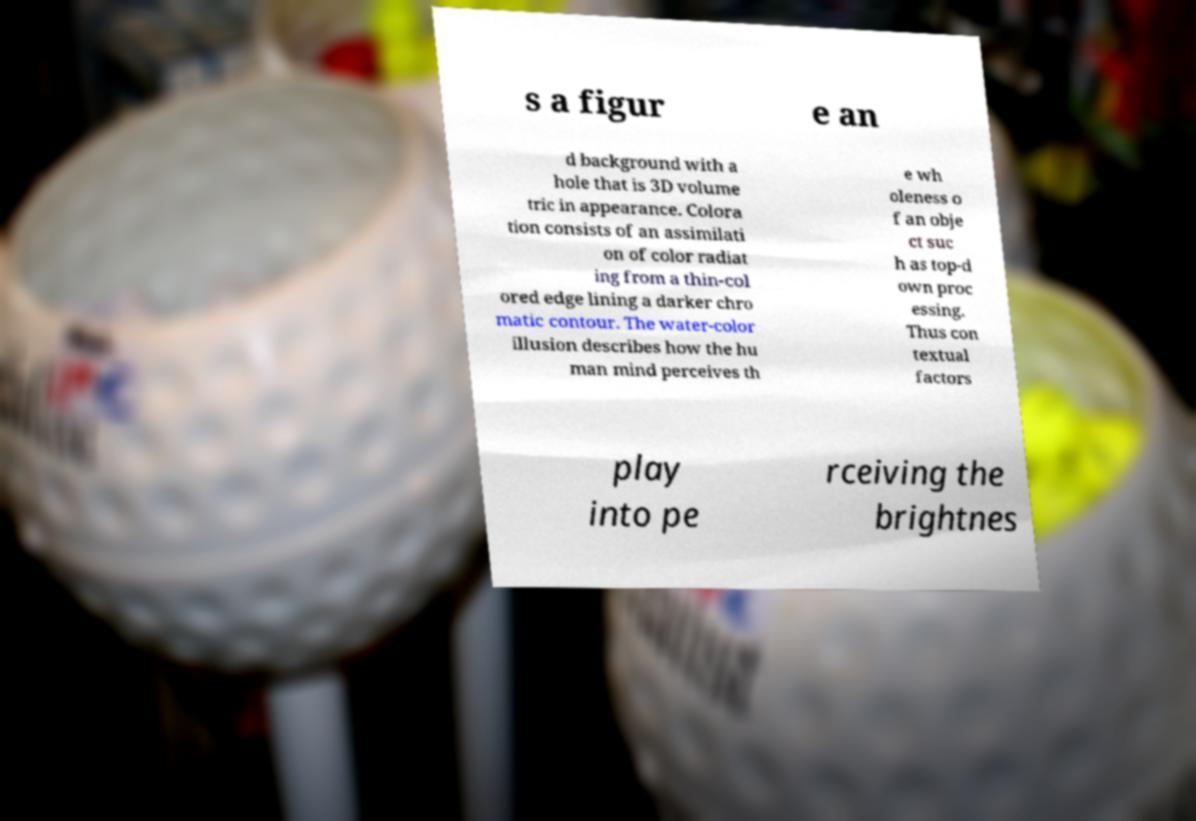What messages or text are displayed in this image? I need them in a readable, typed format. s a figur e an d background with a hole that is 3D volume tric in appearance. Colora tion consists of an assimilati on of color radiat ing from a thin-col ored edge lining a darker chro matic contour. The water-color illusion describes how the hu man mind perceives th e wh oleness o f an obje ct suc h as top-d own proc essing. Thus con textual factors play into pe rceiving the brightnes 